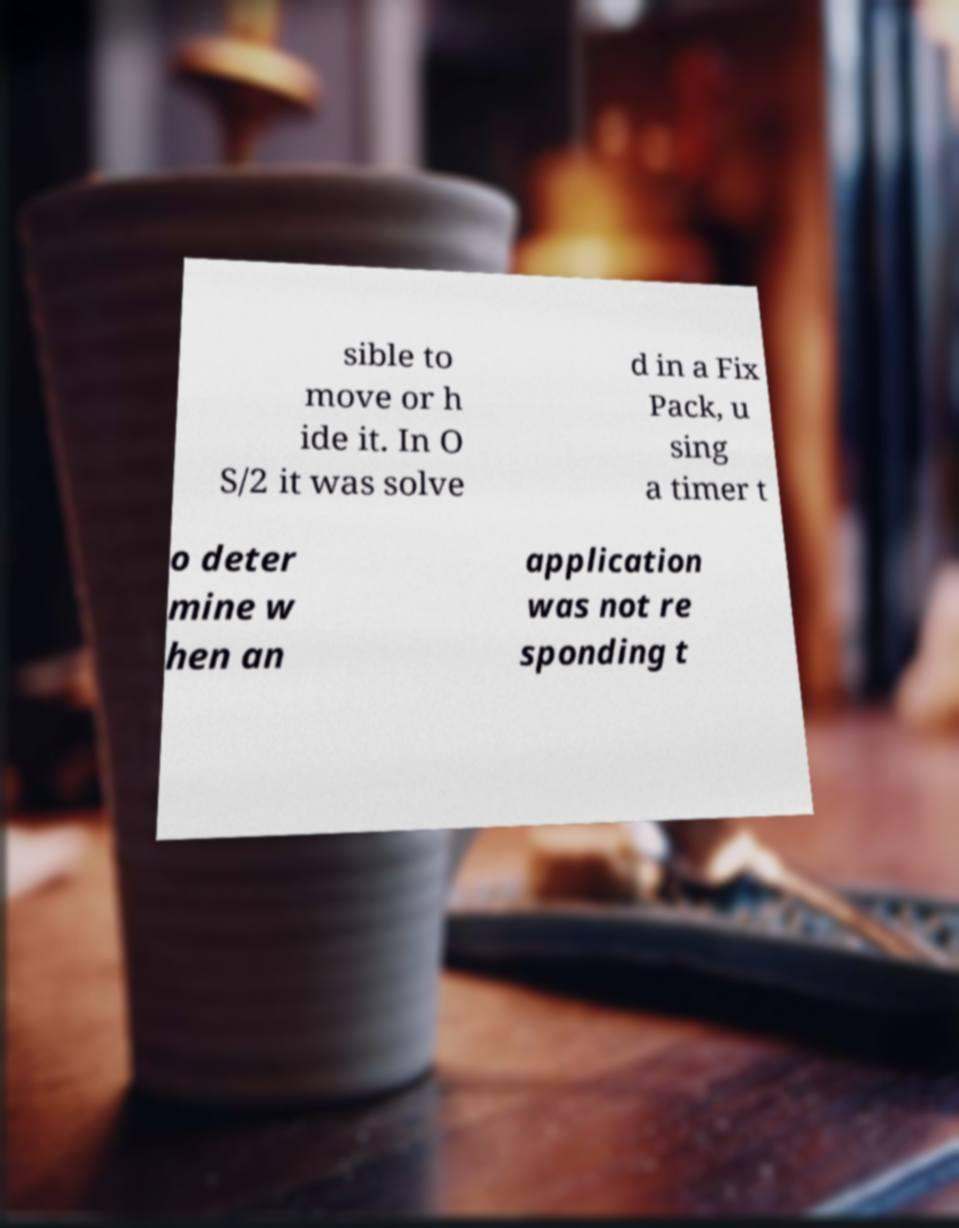I need the written content from this picture converted into text. Can you do that? sible to move or h ide it. In O S/2 it was solve d in a Fix Pack, u sing a timer t o deter mine w hen an application was not re sponding t 